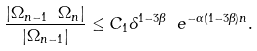<formula> <loc_0><loc_0><loc_500><loc_500>\frac { | \Omega _ { n - 1 } \ \Omega _ { n } | } { | \Omega _ { n - 1 } | } \leq C _ { 1 } \delta ^ { 1 - 3 \beta } \ e ^ { - \alpha ( 1 - 3 \beta ) n } .</formula> 